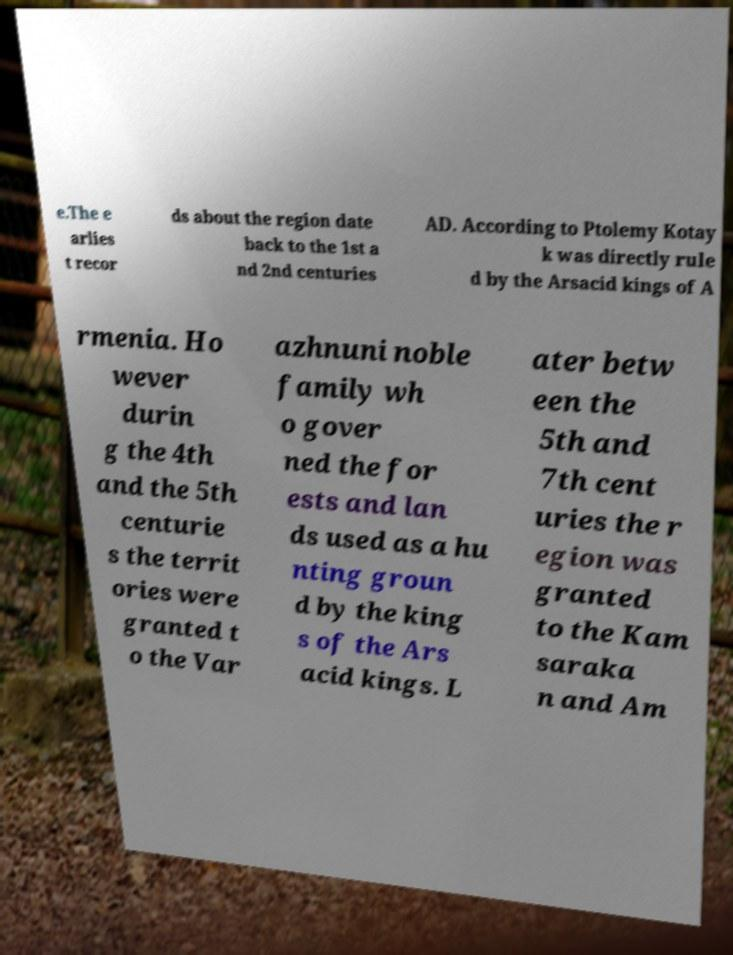Can you accurately transcribe the text from the provided image for me? e.The e arlies t recor ds about the region date back to the 1st a nd 2nd centuries AD. According to Ptolemy Kotay k was directly rule d by the Arsacid kings of A rmenia. Ho wever durin g the 4th and the 5th centurie s the territ ories were granted t o the Var azhnuni noble family wh o gover ned the for ests and lan ds used as a hu nting groun d by the king s of the Ars acid kings. L ater betw een the 5th and 7th cent uries the r egion was granted to the Kam saraka n and Am 